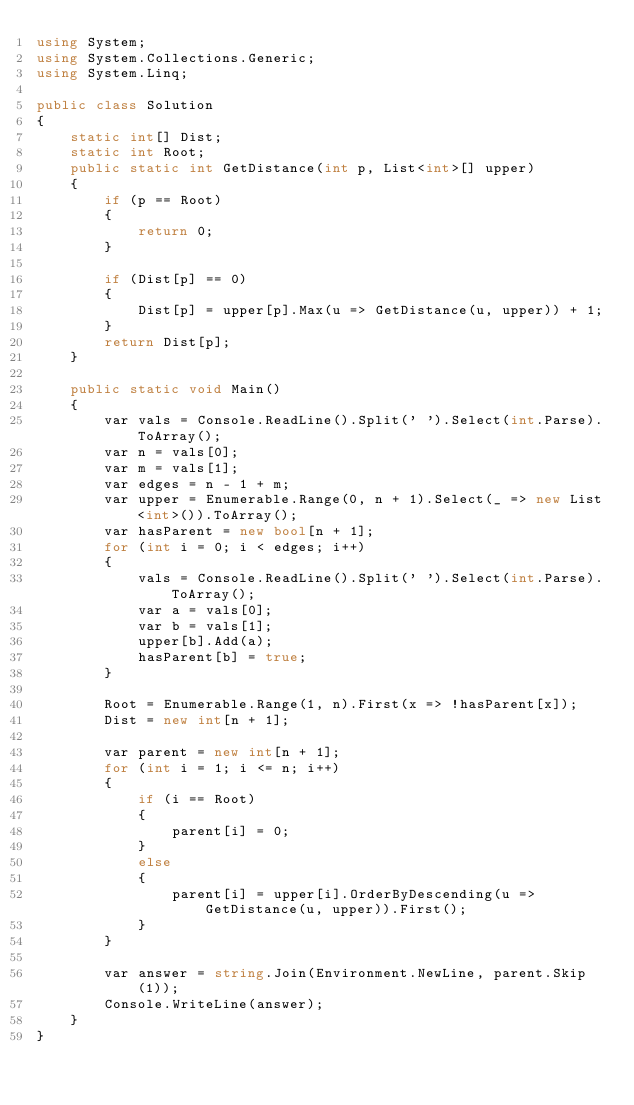<code> <loc_0><loc_0><loc_500><loc_500><_C#_>using System;
using System.Collections.Generic;
using System.Linq;

public class Solution
{
    static int[] Dist;
    static int Root;
    public static int GetDistance(int p, List<int>[] upper)
    {
        if (p == Root)
        {
            return 0;
        }

        if (Dist[p] == 0)
        {
            Dist[p] = upper[p].Max(u => GetDistance(u, upper)) + 1;
        }
        return Dist[p];
    }

    public static void Main()
    {
        var vals = Console.ReadLine().Split(' ').Select(int.Parse).ToArray();
        var n = vals[0];
        var m = vals[1];
        var edges = n - 1 + m;
        var upper = Enumerable.Range(0, n + 1).Select(_ => new List<int>()).ToArray();
        var hasParent = new bool[n + 1];
        for (int i = 0; i < edges; i++)
        {
            vals = Console.ReadLine().Split(' ').Select(int.Parse).ToArray();
            var a = vals[0];
            var b = vals[1];
            upper[b].Add(a);
            hasParent[b] = true;
        }

        Root = Enumerable.Range(1, n).First(x => !hasParent[x]);
        Dist = new int[n + 1];

        var parent = new int[n + 1];
        for (int i = 1; i <= n; i++)
        {
            if (i == Root)
            {
                parent[i] = 0;
            }
            else
            {
                parent[i] = upper[i].OrderByDescending(u => GetDistance(u, upper)).First();
            }
        }

        var answer = string.Join(Environment.NewLine, parent.Skip(1));
        Console.WriteLine(answer);
    }
}</code> 